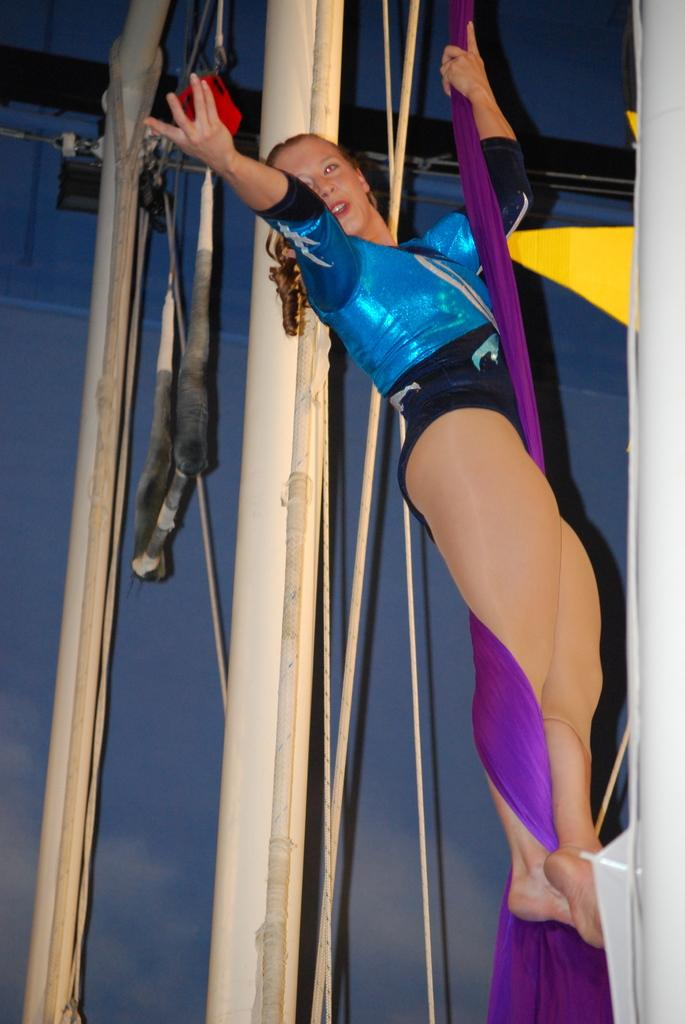Who is the main subject in the image? There is a woman in the image. What is the woman doing in the image? The woman is hanging onto a rope. What can be seen in the background of the image? There are metal rods and the sky visible in the background of the image. What month is it in the image? The month cannot be determined from the image, as there is no information about the time of year. What is in the middle of the image? There is no specific object or subject in the middle of the image; the woman is hanging onto a rope, and the metal rods and sky are in the background. 